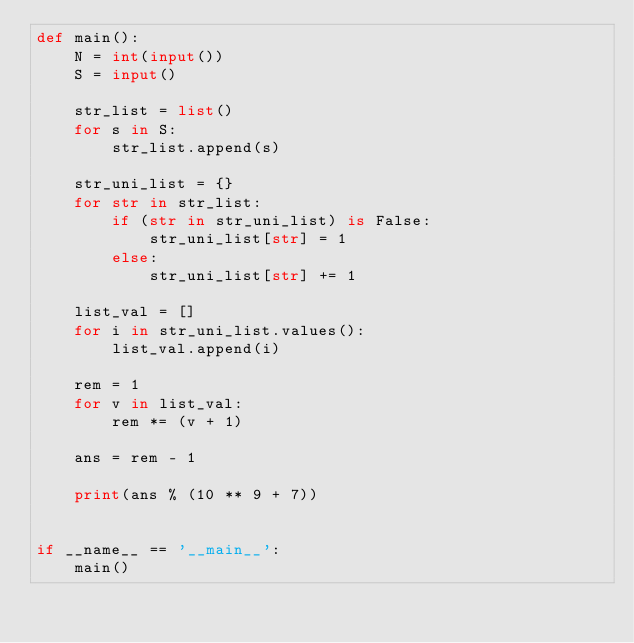<code> <loc_0><loc_0><loc_500><loc_500><_Python_>def main():
    N = int(input())
    S = input()

    str_list = list()
    for s in S:
        str_list.append(s)

    str_uni_list = {}
    for str in str_list:
        if (str in str_uni_list) is False:
            str_uni_list[str] = 1
        else:
            str_uni_list[str] += 1

    list_val = []
    for i in str_uni_list.values():
        list_val.append(i)

    rem = 1
    for v in list_val:
        rem *= (v + 1)

    ans = rem - 1

    print(ans % (10 ** 9 + 7))


if __name__ == '__main__':
    main()
</code> 